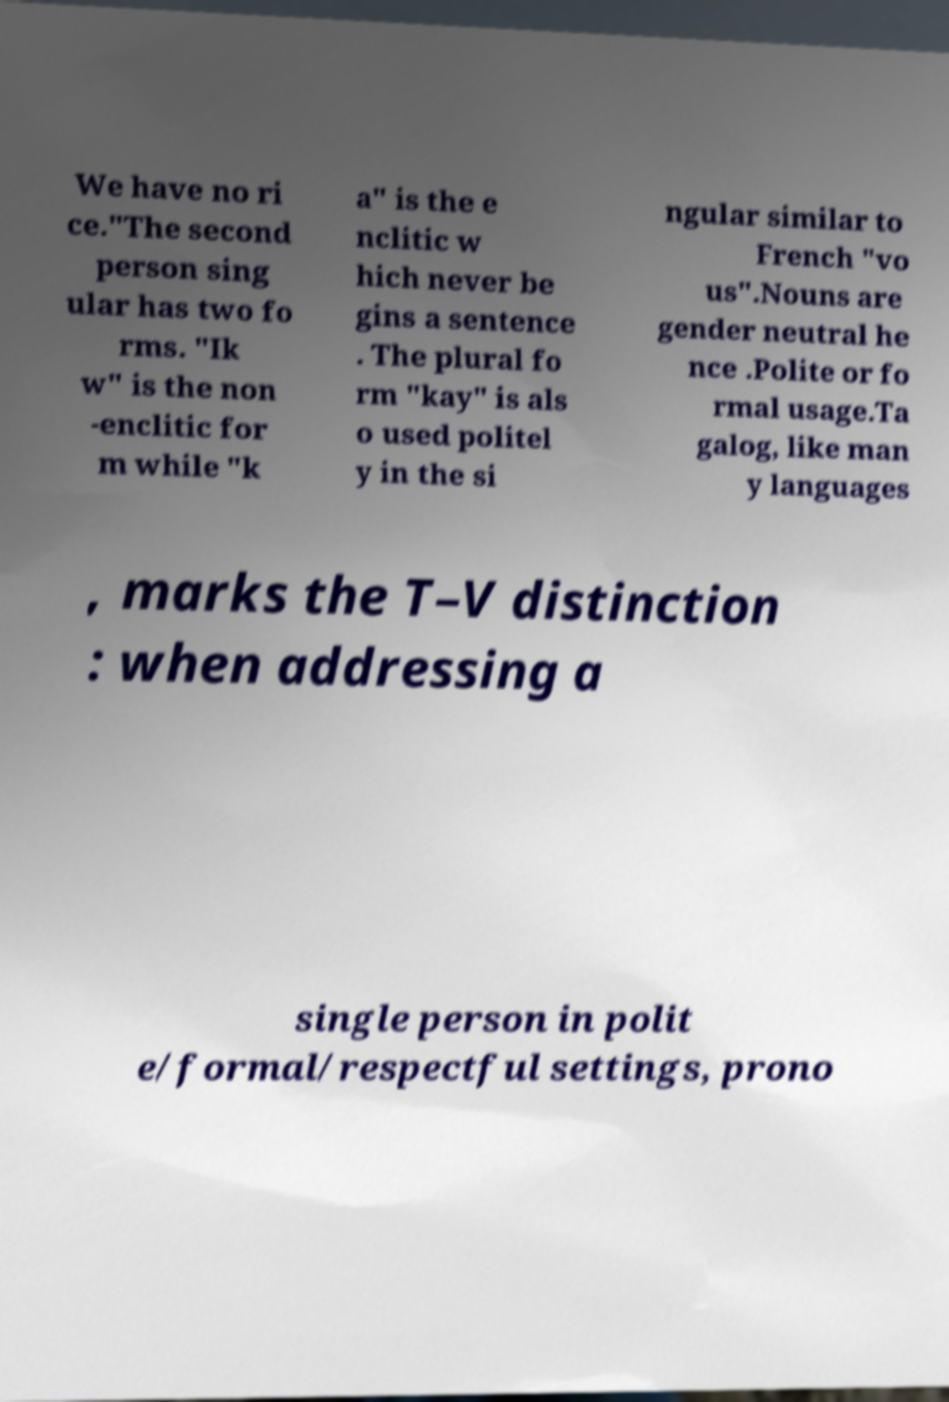What messages or text are displayed in this image? I need them in a readable, typed format. We have no ri ce."The second person sing ular has two fo rms. "Ik w" is the non -enclitic for m while "k a" is the e nclitic w hich never be gins a sentence . The plural fo rm "kay" is als o used politel y in the si ngular similar to French "vo us".Nouns are gender neutral he nce .Polite or fo rmal usage.Ta galog, like man y languages , marks the T–V distinction : when addressing a single person in polit e/formal/respectful settings, prono 